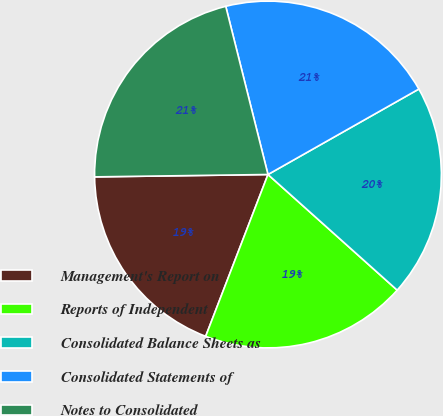Convert chart to OTSL. <chart><loc_0><loc_0><loc_500><loc_500><pie_chart><fcel>Management's Report on<fcel>Reports of Independent<fcel>Consolidated Balance Sheets as<fcel>Consolidated Statements of<fcel>Notes to Consolidated<nl><fcel>18.93%<fcel>19.23%<fcel>19.82%<fcel>20.71%<fcel>21.3%<nl></chart> 